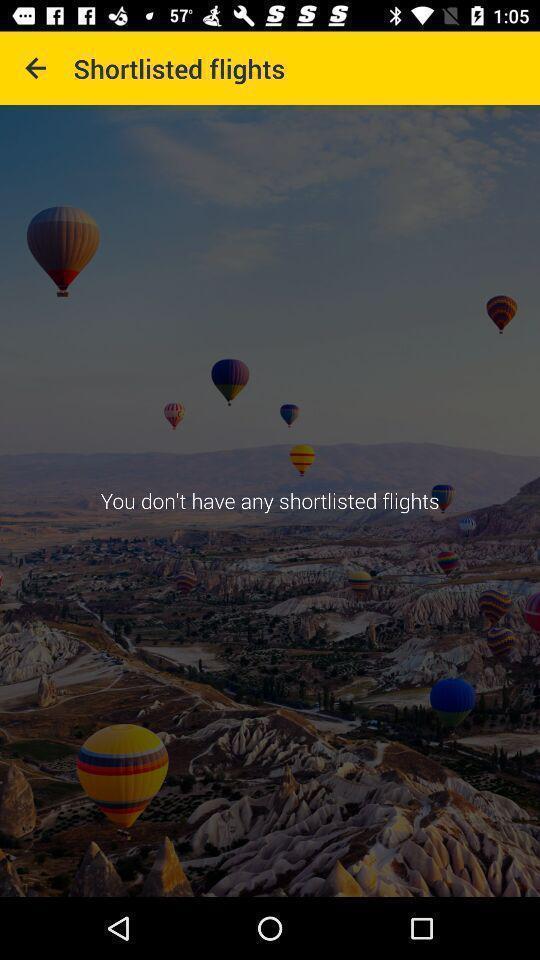Provide a detailed account of this screenshot. Screen displaying information in an airlines travelling application. 